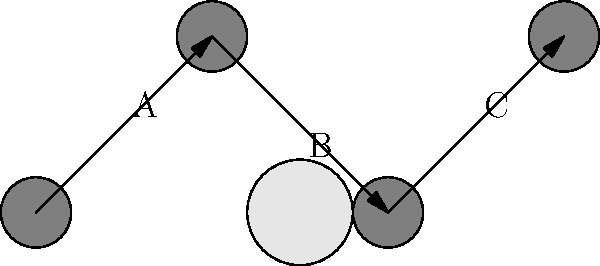As an industry professional seeking diverse actors for groundbreaking productions, you need to understand various camera techniques. In the diagram above, camera positions and shot types are represented. Identify the sequence of shot types (A, B, C) that would create the most dynamic visual storytelling for a character introduction scene. To determine the most dynamic sequence for a character introduction scene, let's analyze each shot type:

1. Shot A (0,0 to 1,1): This represents an upward movement, likely a low-angle shot. Low-angle shots make subjects appear powerful or dominant.

2. Shot B (1,1 to 2,0): This shows a downward movement, suggesting a high-angle shot. High-angle shots can make subjects appear vulnerable or small.

3. Shot C (2,0 to 3,1): Another upward movement, similar to shot A, indicating another low-angle shot.

For a dynamic character introduction:
1. Start with B (high-angle): Introduce the character in their environment, giving context.
2. Move to A (low-angle): Shift perspective to make the character appear more powerful.
3. End with C (another low-angle): Reinforce the character's presence and importance.

This sequence (B-A-C) creates a visual journey from context to empowerment, ending with a strong impression of the character.
Answer: B-A-C 